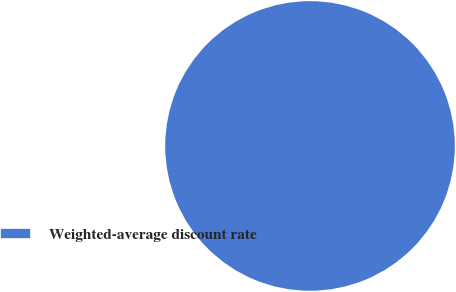<chart> <loc_0><loc_0><loc_500><loc_500><pie_chart><fcel>Weighted-average discount rate<nl><fcel>100.0%<nl></chart> 